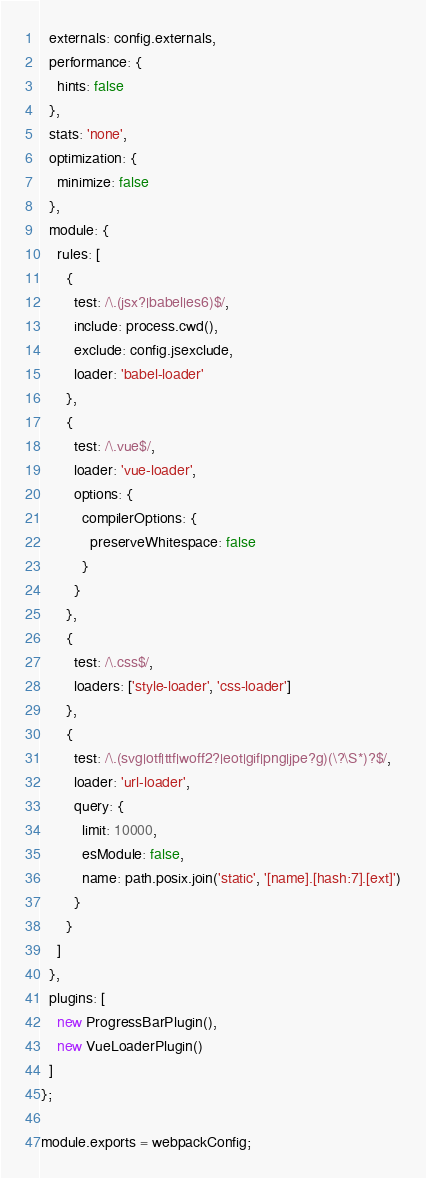<code> <loc_0><loc_0><loc_500><loc_500><_JavaScript_>  externals: config.externals,
  performance: {
    hints: false
  },
  stats: 'none',
  optimization: {
    minimize: false
  },
  module: {
    rules: [
      {
        test: /\.(jsx?|babel|es6)$/,
        include: process.cwd(),
        exclude: config.jsexclude,
        loader: 'babel-loader'
      },
      {
        test: /\.vue$/,
        loader: 'vue-loader',
        options: {
          compilerOptions: {
            preserveWhitespace: false
          }
        }
      },
      {
        test: /\.css$/,
        loaders: ['style-loader', 'css-loader']
      },
      {
        test: /\.(svg|otf|ttf|woff2?|eot|gif|png|jpe?g)(\?\S*)?$/,
        loader: 'url-loader',
        query: {
          limit: 10000,
          esModule: false,
          name: path.posix.join('static', '[name].[hash:7].[ext]')
        }
      }
    ]
  },
  plugins: [
    new ProgressBarPlugin(),
    new VueLoaderPlugin()
  ]
};

module.exports = webpackConfig;
</code> 